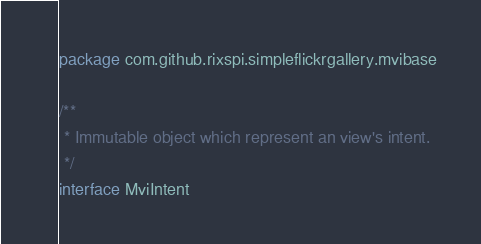Convert code to text. <code><loc_0><loc_0><loc_500><loc_500><_Kotlin_>package com.github.rixspi.simpleflickrgallery.mvibase

/**
 * Immutable object which represent an view's intent.
 */
interface MviIntent
</code> 